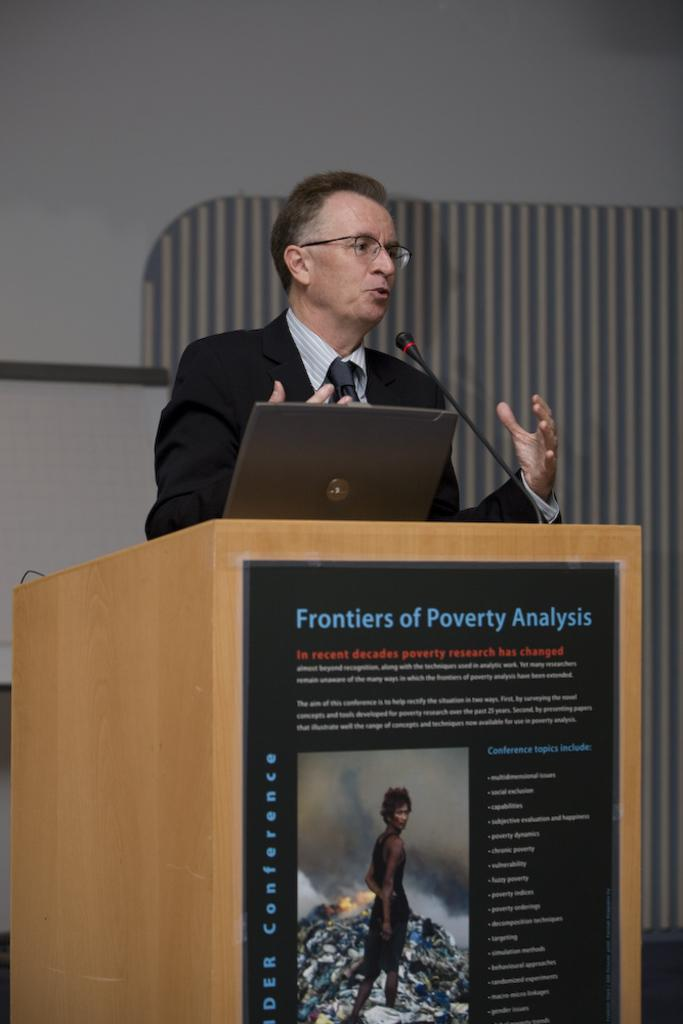<image>
Share a concise interpretation of the image provided. A man is speaking at a podium with a poster than says Frontiers of Poverty Analysis. 